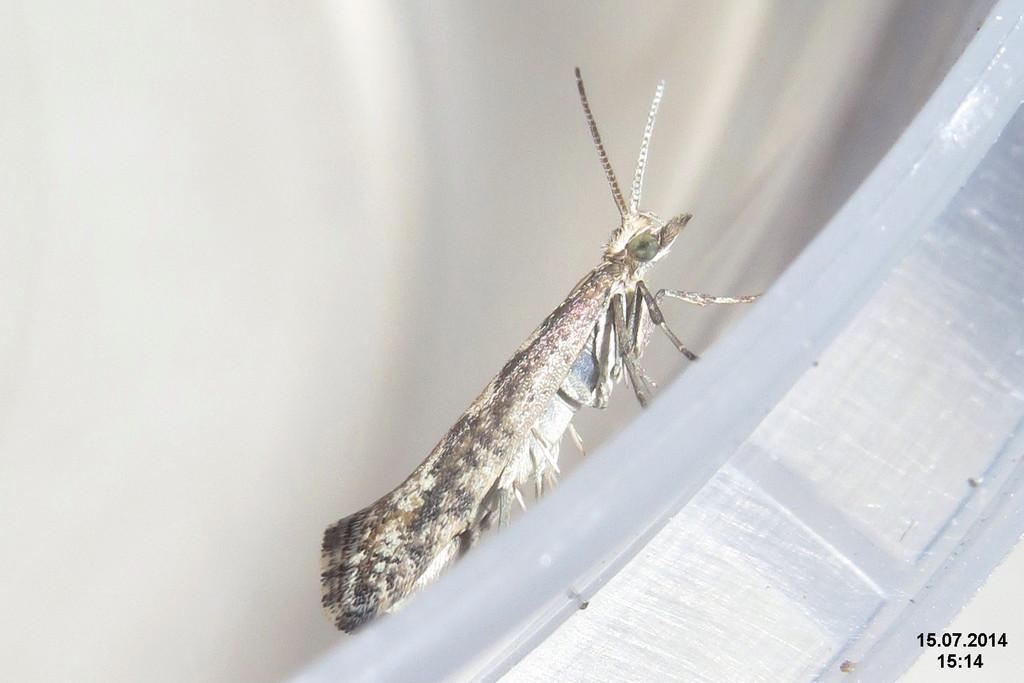Please provide a concise description of this image. In this picture we can see an insect in the front, there is a blurry background, there are some numbers at the right bottom. 